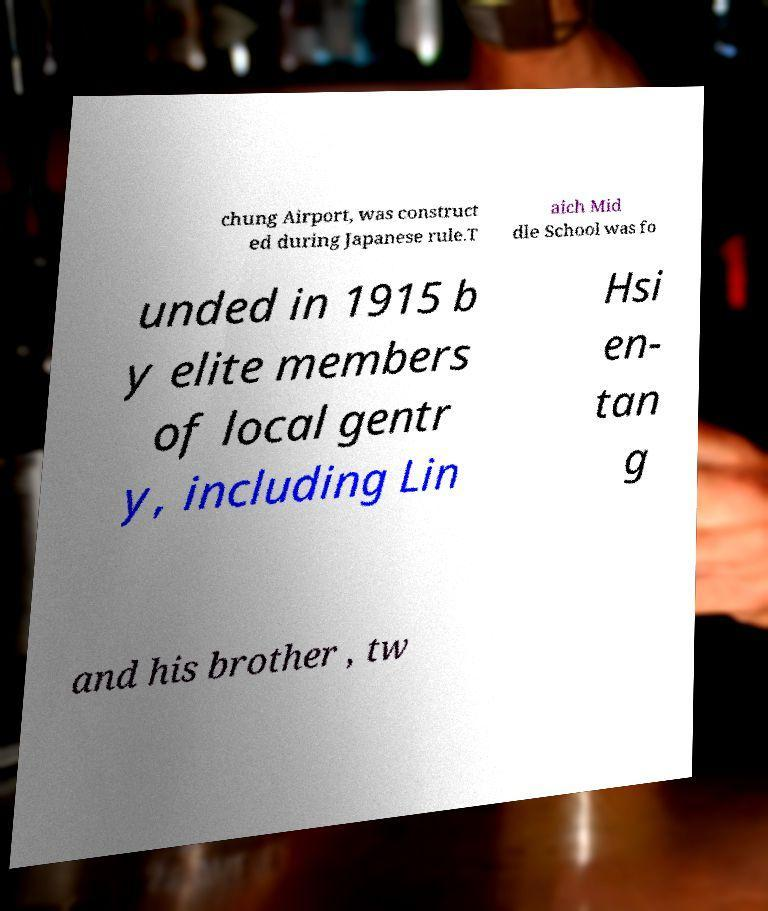Can you accurately transcribe the text from the provided image for me? chung Airport, was construct ed during Japanese rule.T aich Mid dle School was fo unded in 1915 b y elite members of local gentr y, including Lin Hsi en- tan g and his brother , tw 